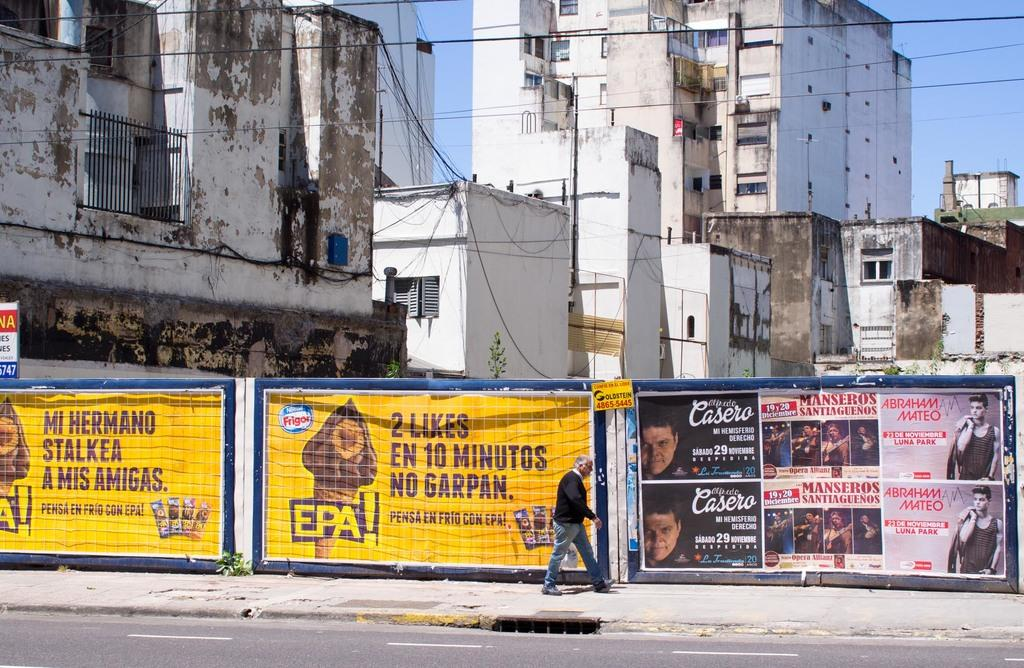<image>
Present a compact description of the photo's key features. A yellow sign that says EPA! is in front of an old factory building. 